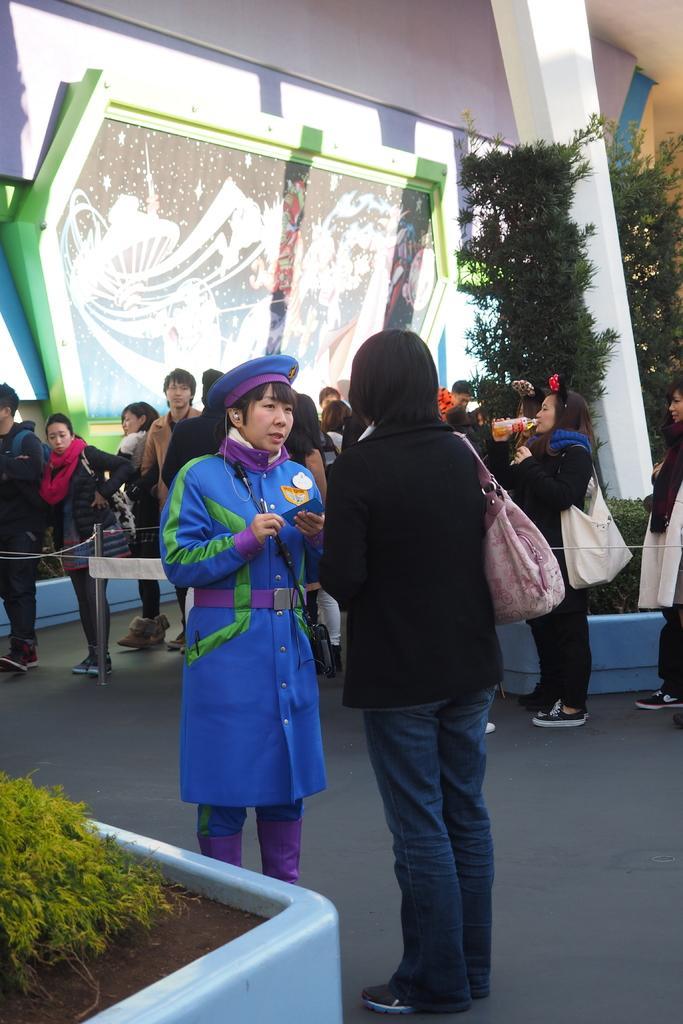Could you give a brief overview of what you see in this image? In this picture I can see there are two women standing, the person to left is wearing a blue uniform and a cap, the person on to right is wearing a hand bag. There are few people standing in a queue and there are few plants, there is a painting on the wall and there is a building on to left. 